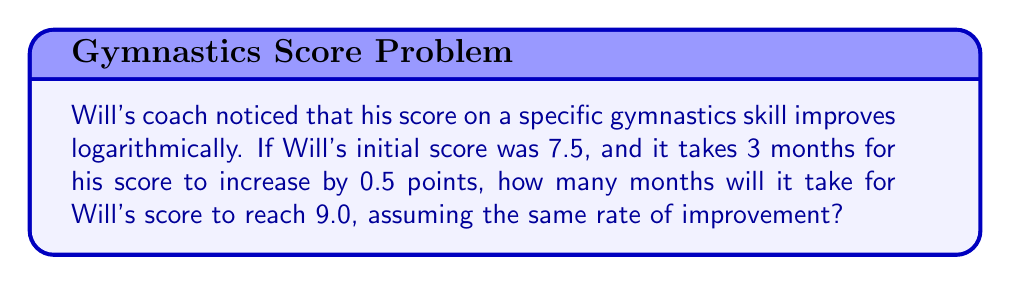Can you answer this question? Let's approach this step-by-step:

1) Let $y$ be Will's score and $t$ be the time in months. We can model this situation with the logarithmic equation:

   $y = a \log(t) + b$

2) We know two points on this curve:
   At $t = 0$, $y = 7.5$
   At $t = 3$, $y = 8.0$

3) Substituting these into our equation:
   $7.5 = a \log(1) + b$ (Note: $\log(1) = 0$)
   $8.0 = a \log(3) + b$

4) From the first equation: $b = 7.5$

5) Substituting this into the second equation:
   $8.0 = a \log(3) + 7.5$
   $0.5 = a \log(3)$
   $a = \frac{0.5}{\log(3)}$

6) Now our equation is:
   $y = \frac{0.5}{\log(3)} \log(t) + 7.5$

7) To find when $y = 9.0$, we substitute:
   $9.0 = \frac{0.5}{\log(3)} \log(t) + 7.5$

8) Solving for $t$:
   $1.5 = \frac{0.5}{\log(3)} \log(t)$
   $1.5 \cdot \log(3) = 0.5 \log(t)$
   $3 \log(3) = \log(t)$
   $t = 3^3 = 27$

Therefore, it will take 27 months for Will's score to reach 9.0.
Answer: 27 months 